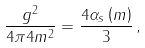Convert formula to latex. <formula><loc_0><loc_0><loc_500><loc_500>\frac { g ^ { 2 } } { 4 \pi 4 m ^ { 2 } } = \frac { 4 \alpha _ { s } \left ( m \right ) } { 3 } \, ,</formula> 